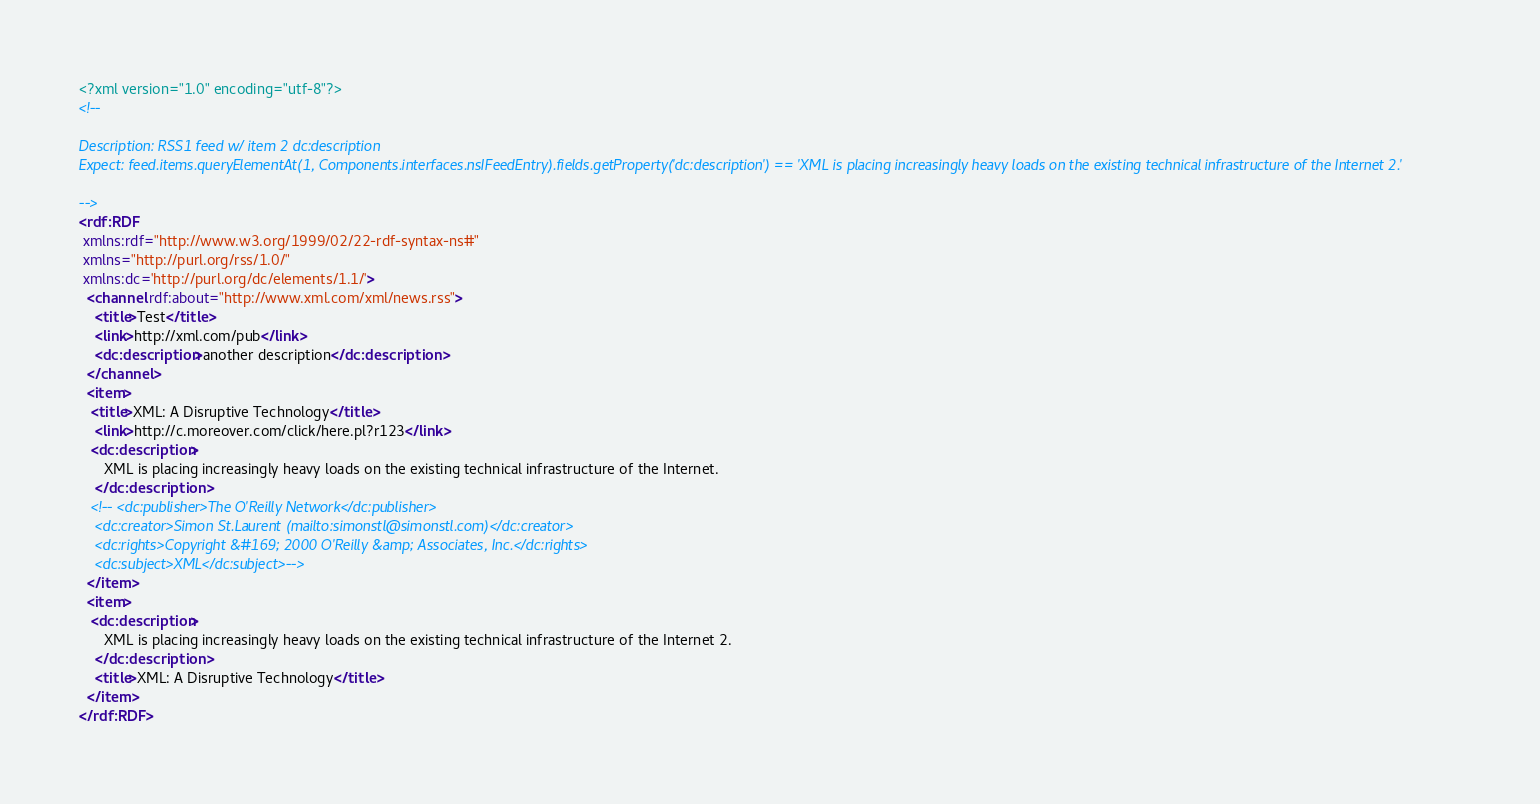Convert code to text. <code><loc_0><loc_0><loc_500><loc_500><_XML_><?xml version="1.0" encoding="utf-8"?>
<!--

Description: RSS1 feed w/ item 2 dc:description
Expect: feed.items.queryElementAt(1, Components.interfaces.nsIFeedEntry).fields.getProperty('dc:description') == 'XML is placing increasingly heavy loads on the existing technical infrastructure of the Internet 2.'

-->
<rdf:RDF 
 xmlns:rdf="http://www.w3.org/1999/02/22-rdf-syntax-ns#"
 xmlns="http://purl.org/rss/1.0/"
 xmlns:dc='http://purl.org/dc/elements/1.1/'>
  <channel rdf:about="http://www.xml.com/xml/news.rss">
    <title>Test</title>
    <link>http://xml.com/pub</link>
    <dc:description>another description</dc:description>  
  </channel>
  <item>
   <title>XML: A Disruptive Technology</title> 
    <link>http://c.moreover.com/click/here.pl?r123</link>
   <dc:description>
      XML is placing increasingly heavy loads on the existing technical infrastructure of the Internet.
    </dc:description>
   <!-- <dc:publisher>The O'Reilly Network</dc:publisher>
    <dc:creator>Simon St.Laurent (mailto:simonstl@simonstl.com)</dc:creator>
    <dc:rights>Copyright &#169; 2000 O'Reilly &amp; Associates, Inc.</dc:rights>
    <dc:subject>XML</dc:subject>-->
  </item> 
  <item>
   <dc:description>
      XML is placing increasingly heavy loads on the existing technical infrastructure of the Internet 2.
    </dc:description>
    <title>XML: A Disruptive Technology</title> 
  </item>
</rdf:RDF></code> 